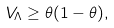Convert formula to latex. <formula><loc_0><loc_0><loc_500><loc_500>V _ { \Lambda } \geq \theta ( 1 - \theta ) ,</formula> 